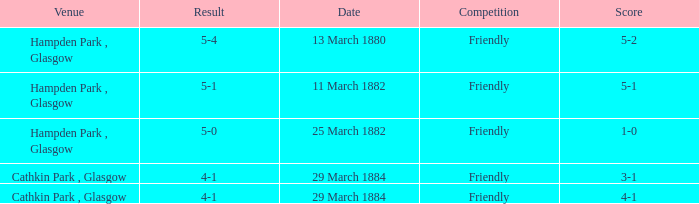Which item has a score of 5-1? 5-1. 